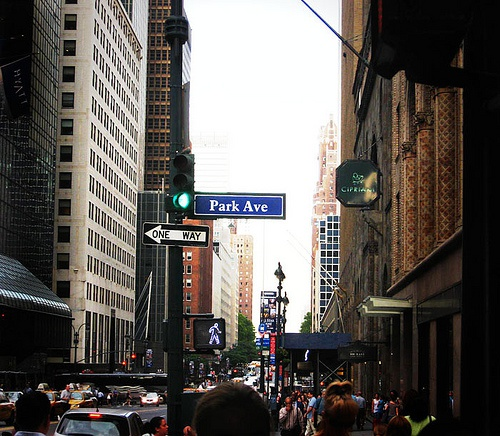Describe the objects in this image and their specific colors. I can see people in black, maroon, and gray tones, people in black, maroon, gray, and darkgray tones, traffic light in black, gray, white, and teal tones, people in black, gray, maroon, and darkgray tones, and people in black, darkgreen, olive, and maroon tones in this image. 